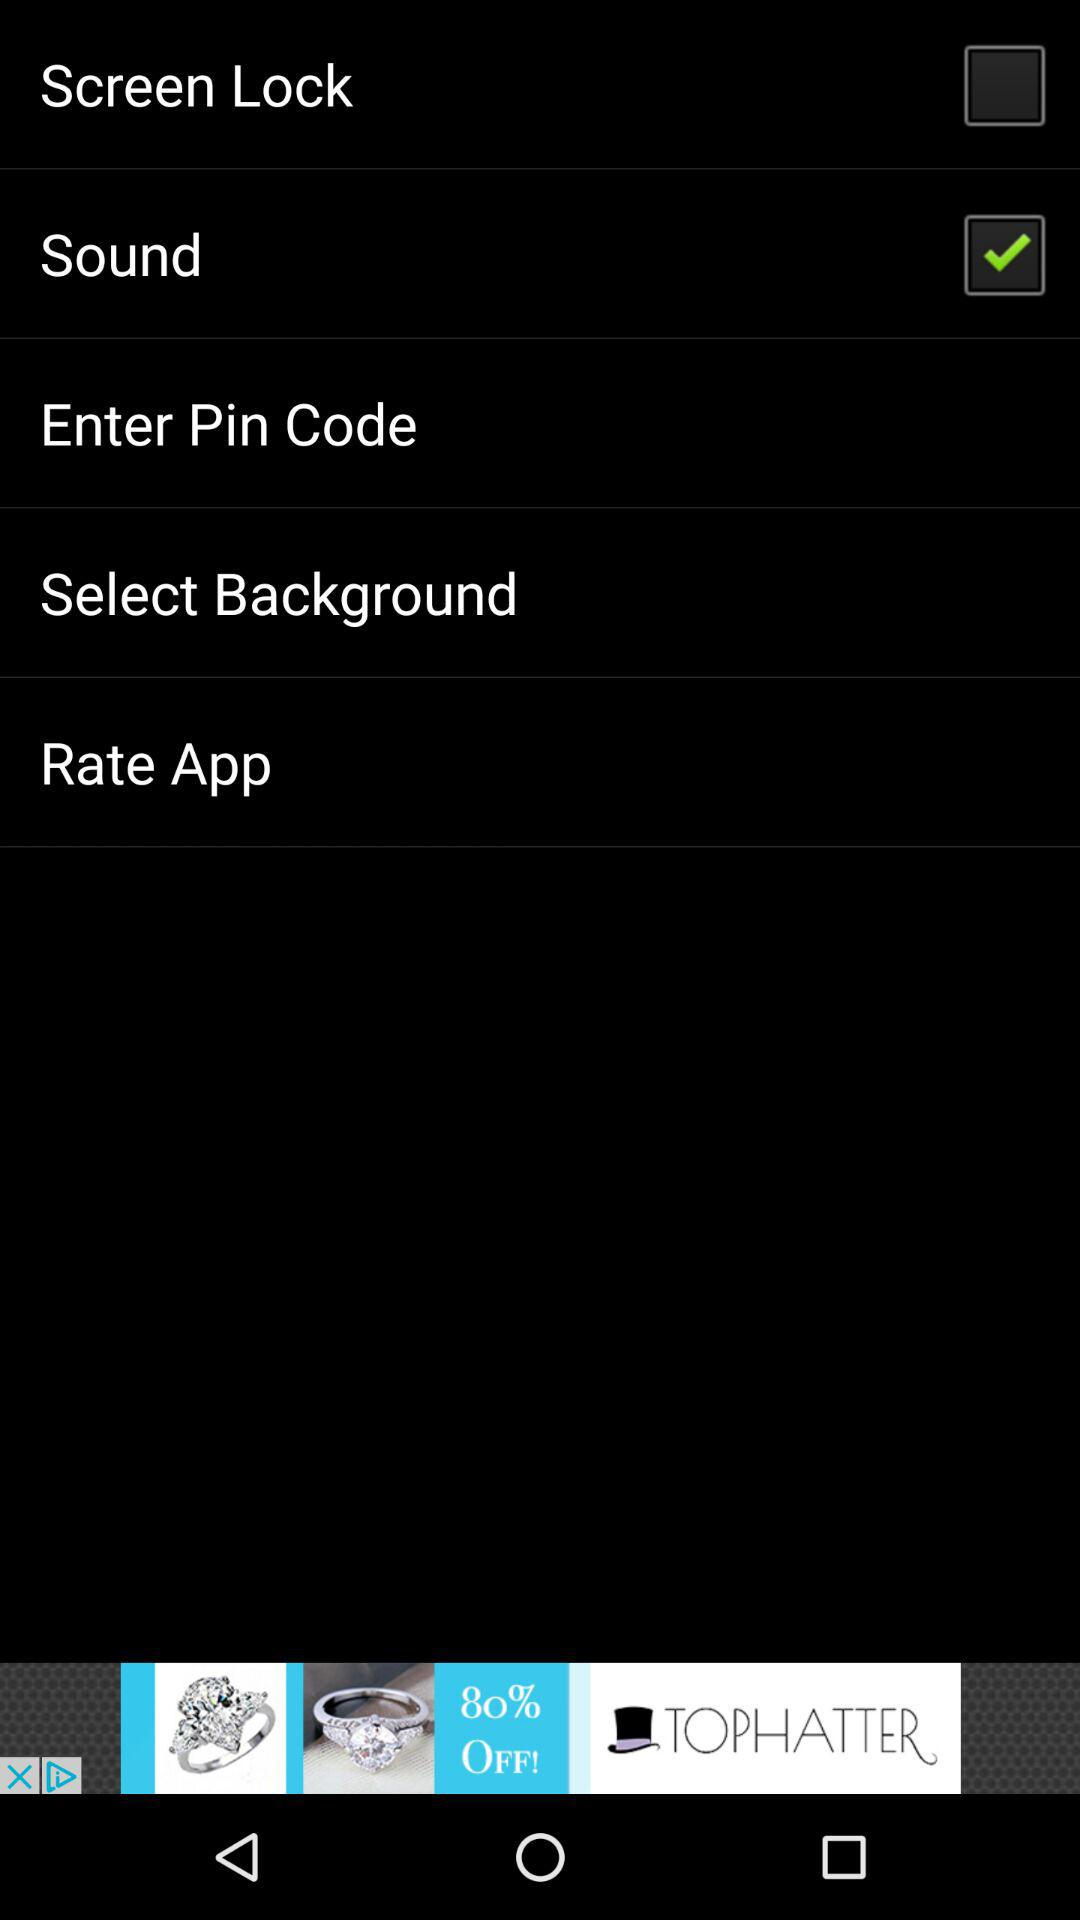What is the status of the sound? The status is on. 